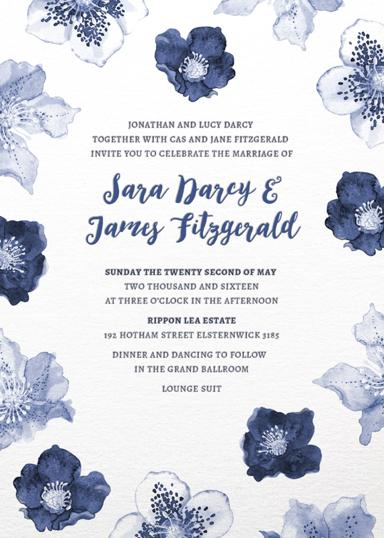Whose wedding is being celebrated in the invitation? The wedding is being celebrated between Jara Mary and Jamey Fitzgerald. When and where does the wedding take place? The wedding takes place on Sunday, the twenty-second of May, in the year two thousand and sixteen, at three o'clock in the afternoon. The location is Rippon Lea Estate, 192 Hotham Street, Elsternwick 3185. What activities are planned for the wedding celebration? Dinner and dancing will follow the wedding ceremony in the Grand Ballroom, with the dress code being lounge suit. Who are the parents of the bride and groom? The parents of the bride and groom are Jonathan and Lucy Darcy, and Cas and Jane Fitzgerald. 